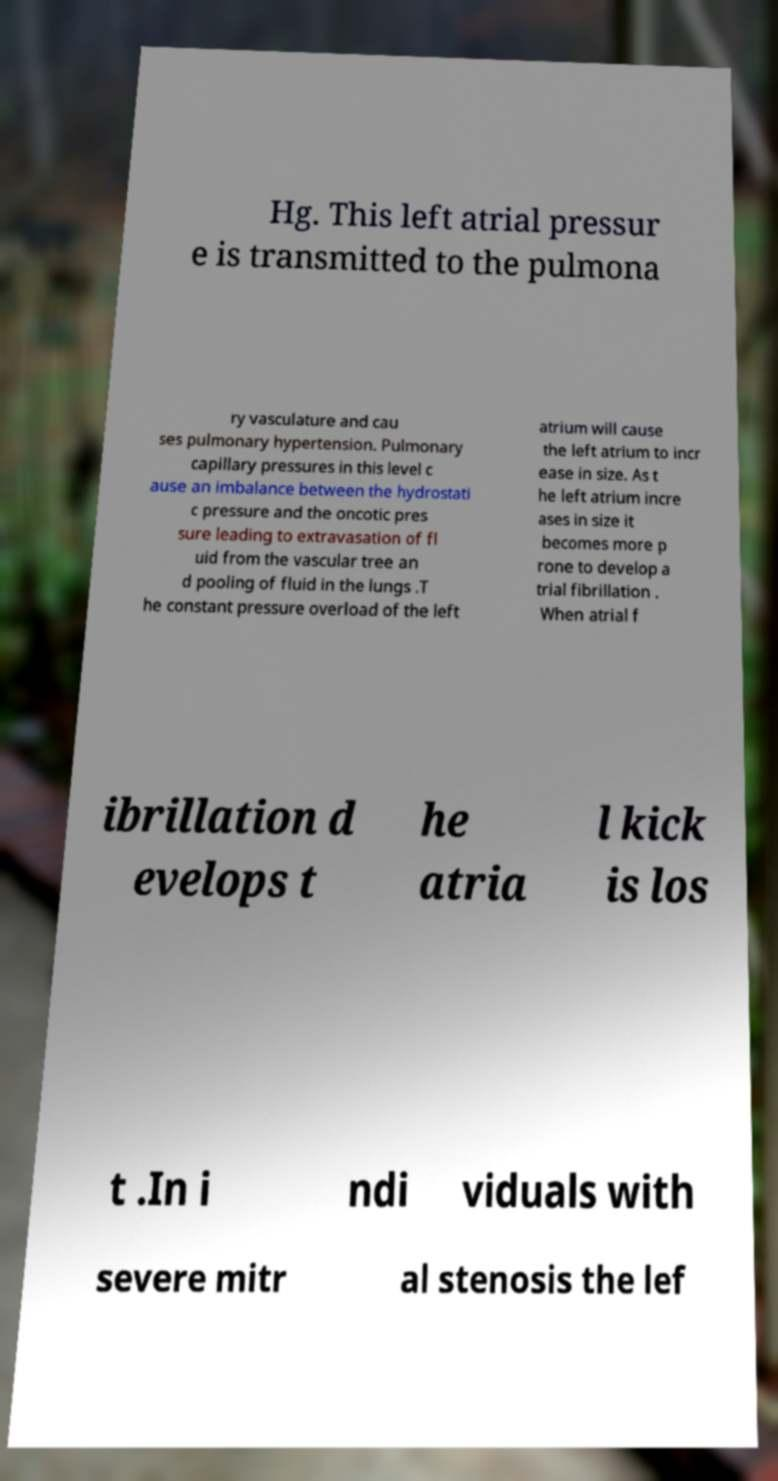For documentation purposes, I need the text within this image transcribed. Could you provide that? Hg. This left atrial pressur e is transmitted to the pulmona ry vasculature and cau ses pulmonary hypertension. Pulmonary capillary pressures in this level c ause an imbalance between the hydrostati c pressure and the oncotic pres sure leading to extravasation of fl uid from the vascular tree an d pooling of fluid in the lungs .T he constant pressure overload of the left atrium will cause the left atrium to incr ease in size. As t he left atrium incre ases in size it becomes more p rone to develop a trial fibrillation . When atrial f ibrillation d evelops t he atria l kick is los t .In i ndi viduals with severe mitr al stenosis the lef 